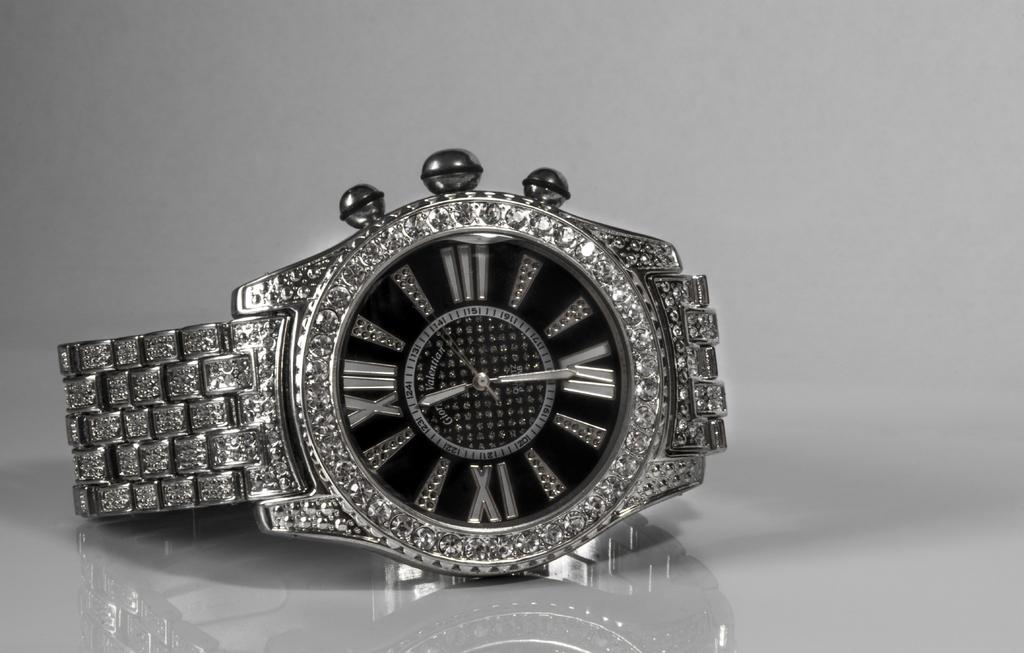Provide a one-sentence caption for the provided image. A silver watch with the word Valentian on the face of the watch. 